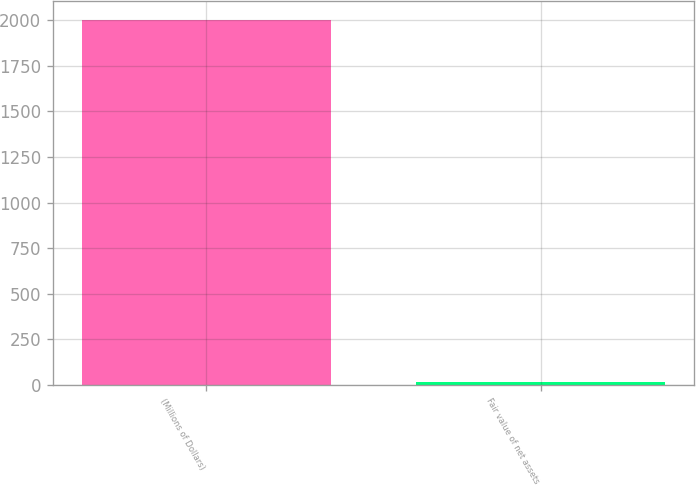Convert chart. <chart><loc_0><loc_0><loc_500><loc_500><bar_chart><fcel>(Millions of Dollars)<fcel>Fair value of net assets<nl><fcel>2003<fcel>15<nl></chart> 